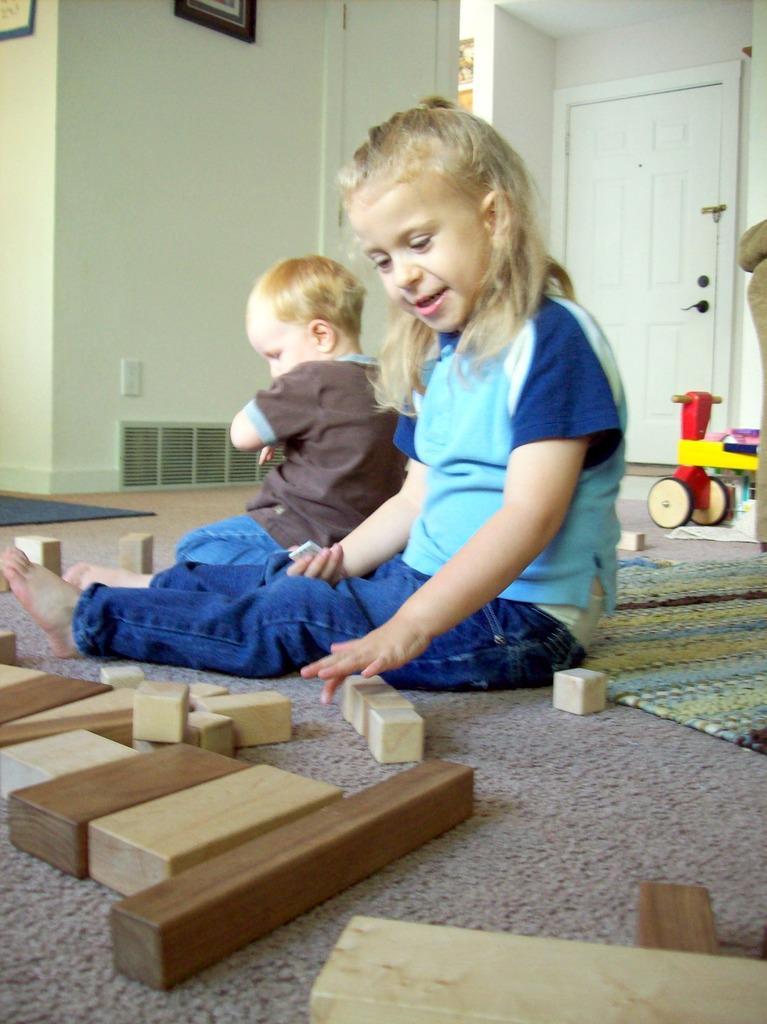Describe this image in one or two sentences. In this picture we can see two kids, they are seated on the floor, in front of them we can find few blocks, in the background we can see few frames on the wall. 